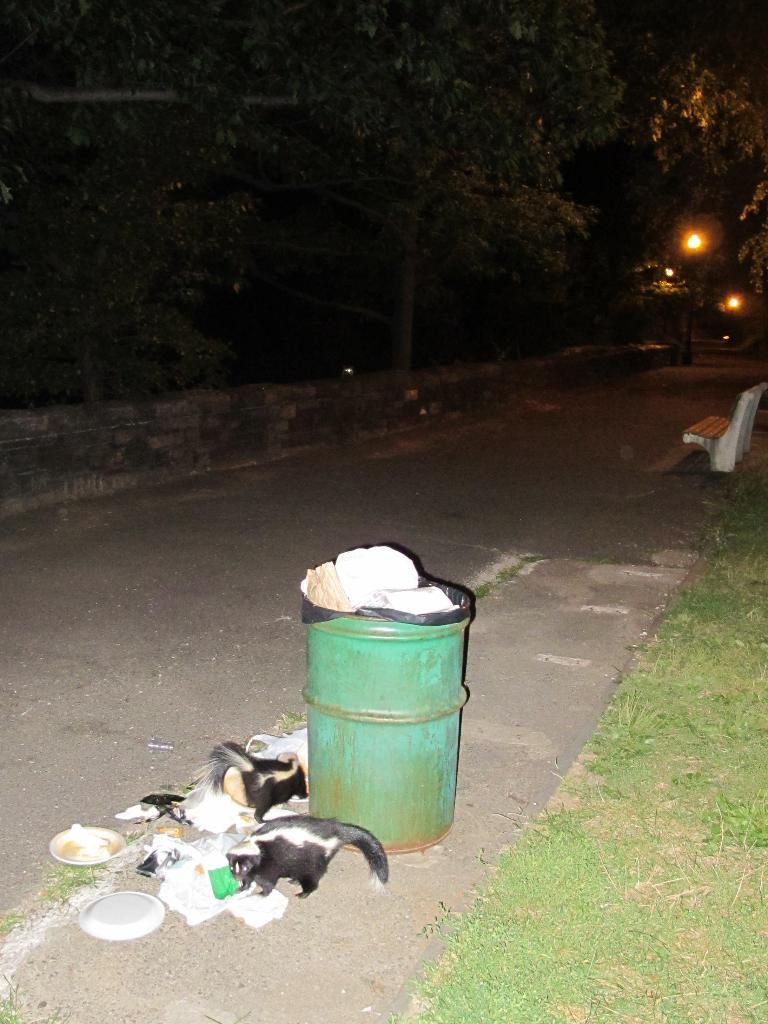What type of container is present in the image? There is a bin in the image. What living creatures can be seen in the image? There are animals in the image. What objects are used for serving food in the image? There are plates in the image. What type of natural ground cover is visible in the image? There is grass in the image. What type of seating is present in the image? There is a bench in the image. What type of pathway is visible in the image? There is a road in the image. What type of barrier is present in the image? There is a wall in the image. What type of vertical structures are present in the image? There are poles in the image. What type of illumination is present in the image? There are lights in the image. What type of objects are present in the image? There are objects in the image. What type of vegetation is visible in the background of the image? There are trees in the background of the image. What type of whistle can be heard in the image? There is no whistle present in the image. 